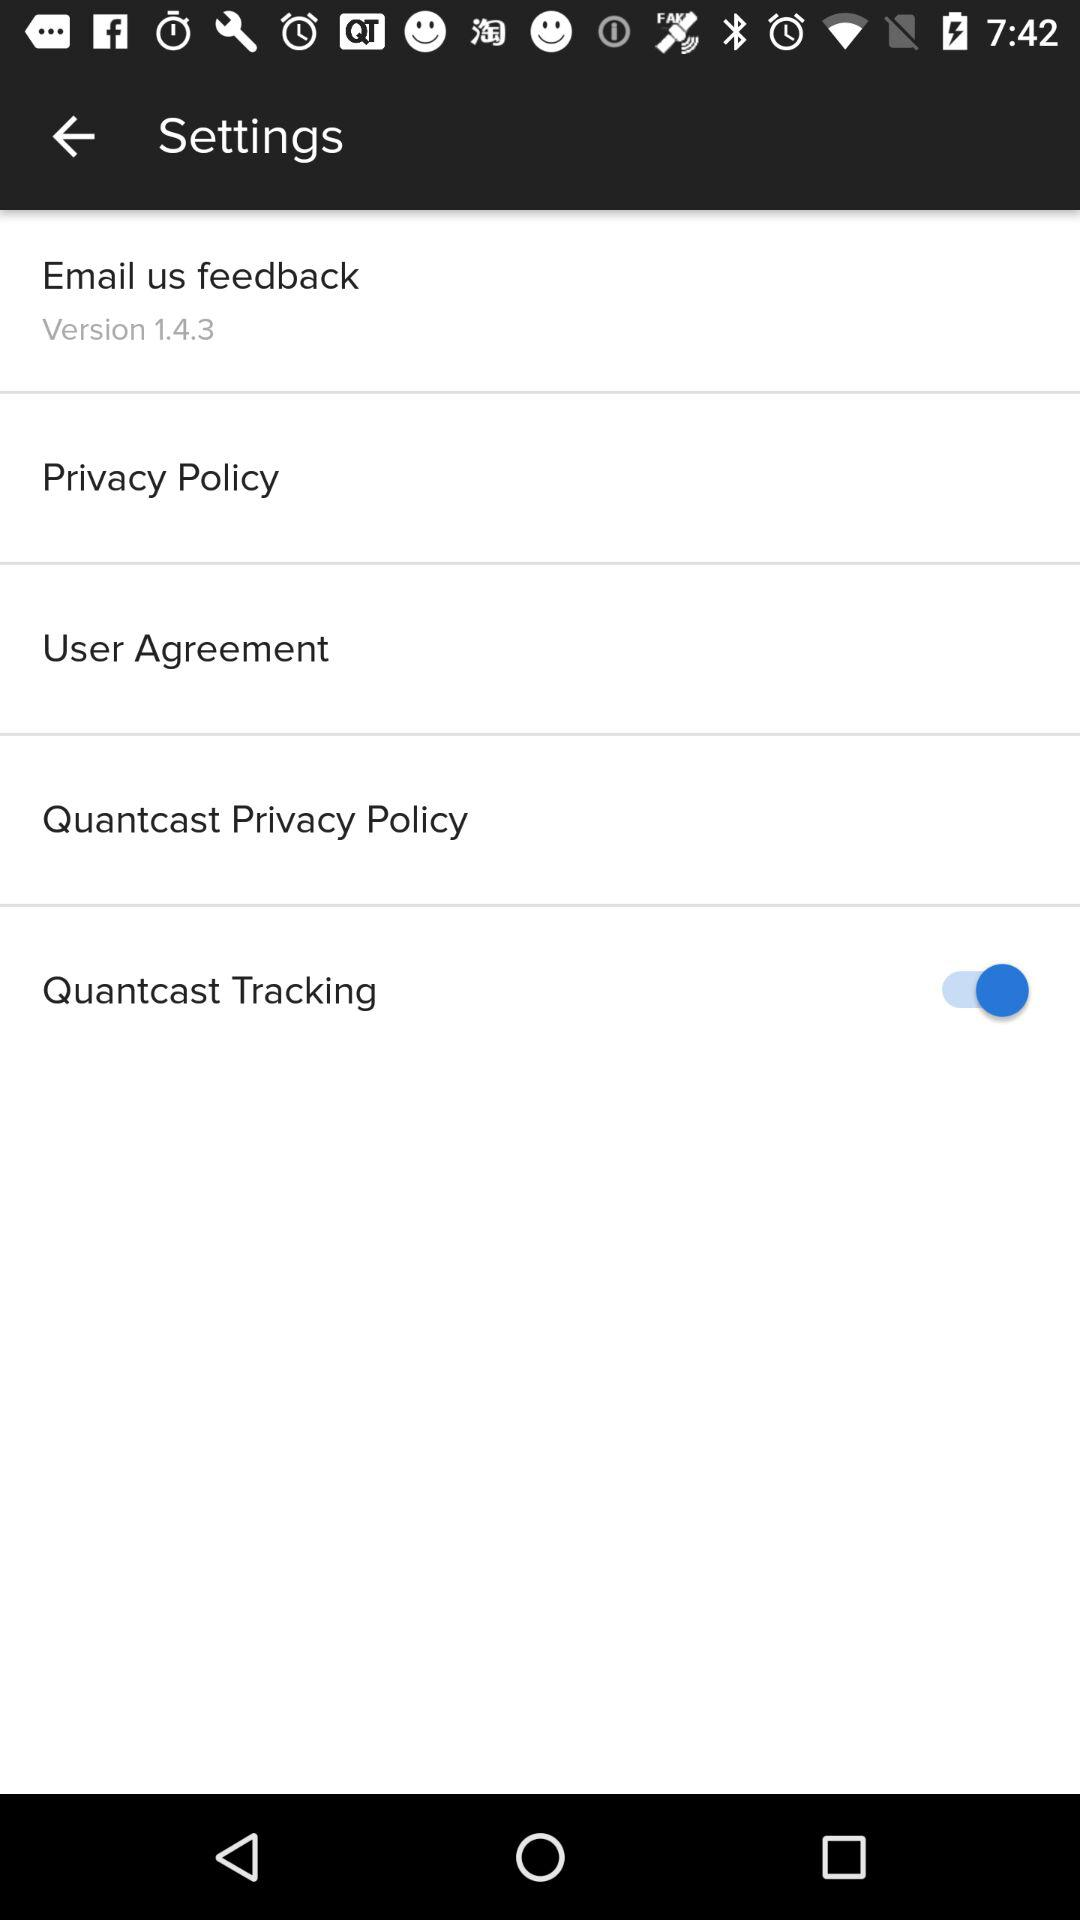What is the version? The version is 1.4.3. 